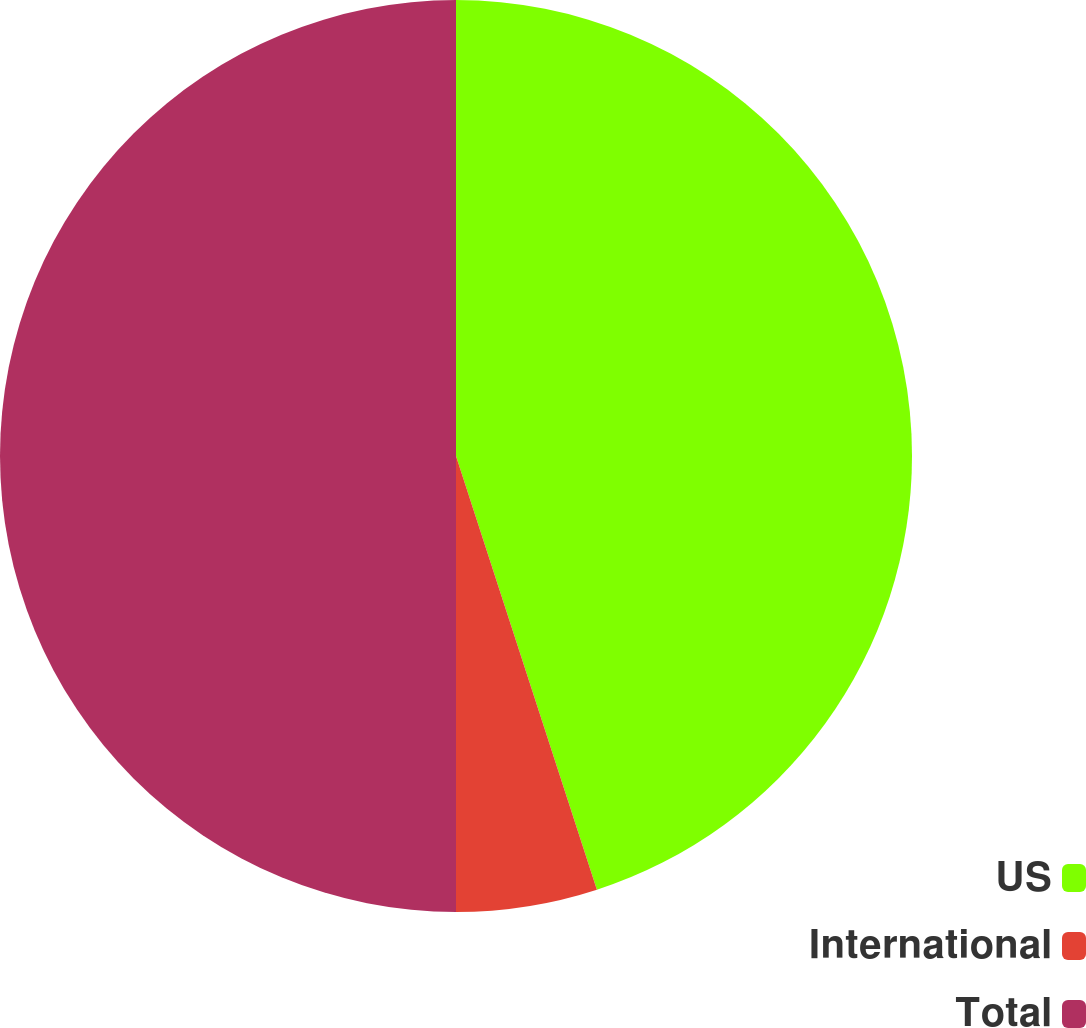Convert chart to OTSL. <chart><loc_0><loc_0><loc_500><loc_500><pie_chart><fcel>US<fcel>International<fcel>Total<nl><fcel>45.0%<fcel>5.0%<fcel>50.0%<nl></chart> 